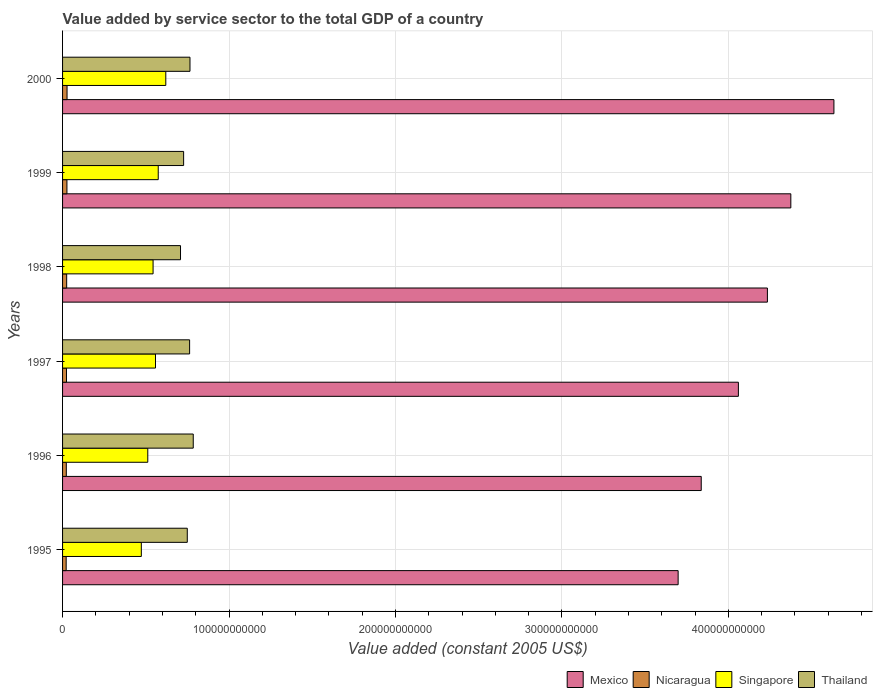Are the number of bars per tick equal to the number of legend labels?
Your response must be concise. Yes. How many bars are there on the 6th tick from the top?
Ensure brevity in your answer.  4. What is the label of the 6th group of bars from the top?
Your response must be concise. 1995. In how many cases, is the number of bars for a given year not equal to the number of legend labels?
Ensure brevity in your answer.  0. What is the value added by service sector in Thailand in 1997?
Provide a short and direct response. 7.63e+1. Across all years, what is the maximum value added by service sector in Thailand?
Your answer should be compact. 7.85e+1. Across all years, what is the minimum value added by service sector in Mexico?
Your answer should be compact. 3.70e+11. In which year was the value added by service sector in Singapore maximum?
Provide a short and direct response. 2000. What is the total value added by service sector in Mexico in the graph?
Provide a succinct answer. 2.48e+12. What is the difference between the value added by service sector in Mexico in 1995 and that in 1999?
Provide a succinct answer. -6.77e+1. What is the difference between the value added by service sector in Thailand in 1996 and the value added by service sector in Singapore in 1998?
Your answer should be compact. 2.41e+1. What is the average value added by service sector in Singapore per year?
Keep it short and to the point. 5.47e+1. In the year 2000, what is the difference between the value added by service sector in Singapore and value added by service sector in Nicaragua?
Your response must be concise. 5.93e+1. In how many years, is the value added by service sector in Mexico greater than 220000000000 US$?
Give a very brief answer. 6. What is the ratio of the value added by service sector in Thailand in 1995 to that in 1999?
Provide a short and direct response. 1.03. Is the value added by service sector in Thailand in 1997 less than that in 1999?
Provide a succinct answer. No. What is the difference between the highest and the second highest value added by service sector in Nicaragua?
Make the answer very short. 5.96e+07. What is the difference between the highest and the lowest value added by service sector in Mexico?
Offer a terse response. 9.36e+1. Is the sum of the value added by service sector in Thailand in 1997 and 1999 greater than the maximum value added by service sector in Singapore across all years?
Offer a terse response. Yes. Is it the case that in every year, the sum of the value added by service sector in Singapore and value added by service sector in Mexico is greater than the sum of value added by service sector in Nicaragua and value added by service sector in Thailand?
Offer a very short reply. Yes. What does the 1st bar from the top in 1999 represents?
Your answer should be compact. Thailand. What does the 4th bar from the bottom in 1995 represents?
Your answer should be very brief. Thailand. Is it the case that in every year, the sum of the value added by service sector in Nicaragua and value added by service sector in Thailand is greater than the value added by service sector in Singapore?
Provide a short and direct response. Yes. How many years are there in the graph?
Give a very brief answer. 6. What is the difference between two consecutive major ticks on the X-axis?
Offer a very short reply. 1.00e+11. What is the title of the graph?
Your answer should be very brief. Value added by service sector to the total GDP of a country. What is the label or title of the X-axis?
Your answer should be compact. Value added (constant 2005 US$). What is the label or title of the Y-axis?
Keep it short and to the point. Years. What is the Value added (constant 2005 US$) of Mexico in 1995?
Make the answer very short. 3.70e+11. What is the Value added (constant 2005 US$) in Nicaragua in 1995?
Give a very brief answer. 2.17e+09. What is the Value added (constant 2005 US$) of Singapore in 1995?
Give a very brief answer. 4.73e+1. What is the Value added (constant 2005 US$) of Thailand in 1995?
Your answer should be compact. 7.49e+1. What is the Value added (constant 2005 US$) of Mexico in 1996?
Keep it short and to the point. 3.84e+11. What is the Value added (constant 2005 US$) in Nicaragua in 1996?
Keep it short and to the point. 2.26e+09. What is the Value added (constant 2005 US$) of Singapore in 1996?
Your answer should be compact. 5.12e+1. What is the Value added (constant 2005 US$) of Thailand in 1996?
Keep it short and to the point. 7.85e+1. What is the Value added (constant 2005 US$) of Mexico in 1997?
Ensure brevity in your answer.  4.06e+11. What is the Value added (constant 2005 US$) of Nicaragua in 1997?
Your response must be concise. 2.37e+09. What is the Value added (constant 2005 US$) in Singapore in 1997?
Provide a short and direct response. 5.58e+1. What is the Value added (constant 2005 US$) of Thailand in 1997?
Make the answer very short. 7.63e+1. What is the Value added (constant 2005 US$) in Mexico in 1998?
Provide a succinct answer. 4.23e+11. What is the Value added (constant 2005 US$) of Nicaragua in 1998?
Offer a very short reply. 2.47e+09. What is the Value added (constant 2005 US$) of Singapore in 1998?
Your answer should be very brief. 5.44e+1. What is the Value added (constant 2005 US$) of Thailand in 1998?
Your answer should be very brief. 7.09e+1. What is the Value added (constant 2005 US$) in Mexico in 1999?
Offer a very short reply. 4.38e+11. What is the Value added (constant 2005 US$) of Nicaragua in 1999?
Make the answer very short. 2.63e+09. What is the Value added (constant 2005 US$) in Singapore in 1999?
Your response must be concise. 5.75e+1. What is the Value added (constant 2005 US$) in Thailand in 1999?
Offer a very short reply. 7.27e+1. What is the Value added (constant 2005 US$) of Mexico in 2000?
Give a very brief answer. 4.63e+11. What is the Value added (constant 2005 US$) in Nicaragua in 2000?
Your answer should be very brief. 2.69e+09. What is the Value added (constant 2005 US$) of Singapore in 2000?
Ensure brevity in your answer.  6.20e+1. What is the Value added (constant 2005 US$) in Thailand in 2000?
Keep it short and to the point. 7.66e+1. Across all years, what is the maximum Value added (constant 2005 US$) of Mexico?
Your answer should be very brief. 4.63e+11. Across all years, what is the maximum Value added (constant 2005 US$) of Nicaragua?
Provide a short and direct response. 2.69e+09. Across all years, what is the maximum Value added (constant 2005 US$) of Singapore?
Provide a short and direct response. 6.20e+1. Across all years, what is the maximum Value added (constant 2005 US$) of Thailand?
Provide a short and direct response. 7.85e+1. Across all years, what is the minimum Value added (constant 2005 US$) in Mexico?
Your answer should be very brief. 3.70e+11. Across all years, what is the minimum Value added (constant 2005 US$) in Nicaragua?
Your answer should be very brief. 2.17e+09. Across all years, what is the minimum Value added (constant 2005 US$) of Singapore?
Ensure brevity in your answer.  4.73e+1. Across all years, what is the minimum Value added (constant 2005 US$) of Thailand?
Provide a succinct answer. 7.09e+1. What is the total Value added (constant 2005 US$) of Mexico in the graph?
Offer a very short reply. 2.48e+12. What is the total Value added (constant 2005 US$) of Nicaragua in the graph?
Provide a short and direct response. 1.46e+1. What is the total Value added (constant 2005 US$) of Singapore in the graph?
Make the answer very short. 3.28e+11. What is the total Value added (constant 2005 US$) in Thailand in the graph?
Provide a succinct answer. 4.50e+11. What is the difference between the Value added (constant 2005 US$) in Mexico in 1995 and that in 1996?
Your response must be concise. -1.39e+1. What is the difference between the Value added (constant 2005 US$) in Nicaragua in 1995 and that in 1996?
Your answer should be very brief. -8.45e+07. What is the difference between the Value added (constant 2005 US$) in Singapore in 1995 and that in 1996?
Provide a succinct answer. -3.88e+09. What is the difference between the Value added (constant 2005 US$) of Thailand in 1995 and that in 1996?
Give a very brief answer. -3.58e+09. What is the difference between the Value added (constant 2005 US$) of Mexico in 1995 and that in 1997?
Your response must be concise. -3.62e+1. What is the difference between the Value added (constant 2005 US$) in Nicaragua in 1995 and that in 1997?
Your response must be concise. -1.96e+08. What is the difference between the Value added (constant 2005 US$) in Singapore in 1995 and that in 1997?
Provide a short and direct response. -8.52e+09. What is the difference between the Value added (constant 2005 US$) in Thailand in 1995 and that in 1997?
Your answer should be very brief. -1.40e+09. What is the difference between the Value added (constant 2005 US$) in Mexico in 1995 and that in 1998?
Keep it short and to the point. -5.36e+1. What is the difference between the Value added (constant 2005 US$) of Nicaragua in 1995 and that in 1998?
Your answer should be very brief. -3.01e+08. What is the difference between the Value added (constant 2005 US$) in Singapore in 1995 and that in 1998?
Offer a very short reply. -7.06e+09. What is the difference between the Value added (constant 2005 US$) of Thailand in 1995 and that in 1998?
Offer a terse response. 4.07e+09. What is the difference between the Value added (constant 2005 US$) of Mexico in 1995 and that in 1999?
Make the answer very short. -6.77e+1. What is the difference between the Value added (constant 2005 US$) of Nicaragua in 1995 and that in 1999?
Give a very brief answer. -4.58e+08. What is the difference between the Value added (constant 2005 US$) of Singapore in 1995 and that in 1999?
Your response must be concise. -1.02e+1. What is the difference between the Value added (constant 2005 US$) of Thailand in 1995 and that in 1999?
Ensure brevity in your answer.  2.19e+09. What is the difference between the Value added (constant 2005 US$) in Mexico in 1995 and that in 2000?
Provide a succinct answer. -9.36e+1. What is the difference between the Value added (constant 2005 US$) in Nicaragua in 1995 and that in 2000?
Make the answer very short. -5.18e+08. What is the difference between the Value added (constant 2005 US$) in Singapore in 1995 and that in 2000?
Your answer should be very brief. -1.47e+1. What is the difference between the Value added (constant 2005 US$) of Thailand in 1995 and that in 2000?
Your response must be concise. -1.63e+09. What is the difference between the Value added (constant 2005 US$) in Mexico in 1996 and that in 1997?
Give a very brief answer. -2.23e+1. What is the difference between the Value added (constant 2005 US$) of Nicaragua in 1996 and that in 1997?
Provide a succinct answer. -1.11e+08. What is the difference between the Value added (constant 2005 US$) of Singapore in 1996 and that in 1997?
Ensure brevity in your answer.  -4.64e+09. What is the difference between the Value added (constant 2005 US$) of Thailand in 1996 and that in 1997?
Give a very brief answer. 2.18e+09. What is the difference between the Value added (constant 2005 US$) in Mexico in 1996 and that in 1998?
Your response must be concise. -3.98e+1. What is the difference between the Value added (constant 2005 US$) in Nicaragua in 1996 and that in 1998?
Offer a very short reply. -2.16e+08. What is the difference between the Value added (constant 2005 US$) in Singapore in 1996 and that in 1998?
Your answer should be very brief. -3.18e+09. What is the difference between the Value added (constant 2005 US$) of Thailand in 1996 and that in 1998?
Your answer should be very brief. 7.65e+09. What is the difference between the Value added (constant 2005 US$) of Mexico in 1996 and that in 1999?
Provide a succinct answer. -5.38e+1. What is the difference between the Value added (constant 2005 US$) of Nicaragua in 1996 and that in 1999?
Offer a terse response. -3.74e+08. What is the difference between the Value added (constant 2005 US$) in Singapore in 1996 and that in 1999?
Your answer should be very brief. -6.28e+09. What is the difference between the Value added (constant 2005 US$) in Thailand in 1996 and that in 1999?
Offer a terse response. 5.78e+09. What is the difference between the Value added (constant 2005 US$) in Mexico in 1996 and that in 2000?
Give a very brief answer. -7.97e+1. What is the difference between the Value added (constant 2005 US$) in Nicaragua in 1996 and that in 2000?
Ensure brevity in your answer.  -4.33e+08. What is the difference between the Value added (constant 2005 US$) in Singapore in 1996 and that in 2000?
Your answer should be very brief. -1.08e+1. What is the difference between the Value added (constant 2005 US$) of Thailand in 1996 and that in 2000?
Give a very brief answer. 1.96e+09. What is the difference between the Value added (constant 2005 US$) of Mexico in 1997 and that in 1998?
Your response must be concise. -1.74e+1. What is the difference between the Value added (constant 2005 US$) in Nicaragua in 1997 and that in 1998?
Provide a succinct answer. -1.05e+08. What is the difference between the Value added (constant 2005 US$) of Singapore in 1997 and that in 1998?
Offer a very short reply. 1.46e+09. What is the difference between the Value added (constant 2005 US$) in Thailand in 1997 and that in 1998?
Keep it short and to the point. 5.47e+09. What is the difference between the Value added (constant 2005 US$) in Mexico in 1997 and that in 1999?
Ensure brevity in your answer.  -3.15e+1. What is the difference between the Value added (constant 2005 US$) in Nicaragua in 1997 and that in 1999?
Ensure brevity in your answer.  -2.62e+08. What is the difference between the Value added (constant 2005 US$) in Singapore in 1997 and that in 1999?
Offer a terse response. -1.64e+09. What is the difference between the Value added (constant 2005 US$) in Thailand in 1997 and that in 1999?
Provide a short and direct response. 3.59e+09. What is the difference between the Value added (constant 2005 US$) of Mexico in 1997 and that in 2000?
Your answer should be very brief. -5.74e+1. What is the difference between the Value added (constant 2005 US$) of Nicaragua in 1997 and that in 2000?
Your answer should be very brief. -3.22e+08. What is the difference between the Value added (constant 2005 US$) of Singapore in 1997 and that in 2000?
Provide a succinct answer. -6.18e+09. What is the difference between the Value added (constant 2005 US$) in Thailand in 1997 and that in 2000?
Make the answer very short. -2.27e+08. What is the difference between the Value added (constant 2005 US$) of Mexico in 1998 and that in 1999?
Provide a short and direct response. -1.41e+1. What is the difference between the Value added (constant 2005 US$) of Nicaragua in 1998 and that in 1999?
Offer a terse response. -1.57e+08. What is the difference between the Value added (constant 2005 US$) in Singapore in 1998 and that in 1999?
Keep it short and to the point. -3.10e+09. What is the difference between the Value added (constant 2005 US$) of Thailand in 1998 and that in 1999?
Provide a short and direct response. -1.87e+09. What is the difference between the Value added (constant 2005 US$) in Mexico in 1998 and that in 2000?
Make the answer very short. -4.00e+1. What is the difference between the Value added (constant 2005 US$) of Nicaragua in 1998 and that in 2000?
Your answer should be compact. -2.17e+08. What is the difference between the Value added (constant 2005 US$) of Singapore in 1998 and that in 2000?
Provide a succinct answer. -7.64e+09. What is the difference between the Value added (constant 2005 US$) of Thailand in 1998 and that in 2000?
Your answer should be compact. -5.69e+09. What is the difference between the Value added (constant 2005 US$) of Mexico in 1999 and that in 2000?
Offer a very short reply. -2.59e+1. What is the difference between the Value added (constant 2005 US$) in Nicaragua in 1999 and that in 2000?
Provide a succinct answer. -5.96e+07. What is the difference between the Value added (constant 2005 US$) of Singapore in 1999 and that in 2000?
Make the answer very short. -4.54e+09. What is the difference between the Value added (constant 2005 US$) in Thailand in 1999 and that in 2000?
Your answer should be compact. -3.82e+09. What is the difference between the Value added (constant 2005 US$) of Mexico in 1995 and the Value added (constant 2005 US$) of Nicaragua in 1996?
Offer a terse response. 3.68e+11. What is the difference between the Value added (constant 2005 US$) in Mexico in 1995 and the Value added (constant 2005 US$) in Singapore in 1996?
Your answer should be compact. 3.19e+11. What is the difference between the Value added (constant 2005 US$) of Mexico in 1995 and the Value added (constant 2005 US$) of Thailand in 1996?
Make the answer very short. 2.91e+11. What is the difference between the Value added (constant 2005 US$) of Nicaragua in 1995 and the Value added (constant 2005 US$) of Singapore in 1996?
Your answer should be compact. -4.90e+1. What is the difference between the Value added (constant 2005 US$) in Nicaragua in 1995 and the Value added (constant 2005 US$) in Thailand in 1996?
Make the answer very short. -7.63e+1. What is the difference between the Value added (constant 2005 US$) in Singapore in 1995 and the Value added (constant 2005 US$) in Thailand in 1996?
Ensure brevity in your answer.  -3.12e+1. What is the difference between the Value added (constant 2005 US$) of Mexico in 1995 and the Value added (constant 2005 US$) of Nicaragua in 1997?
Your response must be concise. 3.67e+11. What is the difference between the Value added (constant 2005 US$) in Mexico in 1995 and the Value added (constant 2005 US$) in Singapore in 1997?
Your answer should be compact. 3.14e+11. What is the difference between the Value added (constant 2005 US$) of Mexico in 1995 and the Value added (constant 2005 US$) of Thailand in 1997?
Your answer should be compact. 2.94e+11. What is the difference between the Value added (constant 2005 US$) in Nicaragua in 1995 and the Value added (constant 2005 US$) in Singapore in 1997?
Provide a short and direct response. -5.37e+1. What is the difference between the Value added (constant 2005 US$) in Nicaragua in 1995 and the Value added (constant 2005 US$) in Thailand in 1997?
Your response must be concise. -7.42e+1. What is the difference between the Value added (constant 2005 US$) in Singapore in 1995 and the Value added (constant 2005 US$) in Thailand in 1997?
Offer a terse response. -2.90e+1. What is the difference between the Value added (constant 2005 US$) of Mexico in 1995 and the Value added (constant 2005 US$) of Nicaragua in 1998?
Provide a short and direct response. 3.67e+11. What is the difference between the Value added (constant 2005 US$) in Mexico in 1995 and the Value added (constant 2005 US$) in Singapore in 1998?
Offer a terse response. 3.15e+11. What is the difference between the Value added (constant 2005 US$) of Mexico in 1995 and the Value added (constant 2005 US$) of Thailand in 1998?
Your answer should be compact. 2.99e+11. What is the difference between the Value added (constant 2005 US$) of Nicaragua in 1995 and the Value added (constant 2005 US$) of Singapore in 1998?
Make the answer very short. -5.22e+1. What is the difference between the Value added (constant 2005 US$) of Nicaragua in 1995 and the Value added (constant 2005 US$) of Thailand in 1998?
Offer a terse response. -6.87e+1. What is the difference between the Value added (constant 2005 US$) in Singapore in 1995 and the Value added (constant 2005 US$) in Thailand in 1998?
Ensure brevity in your answer.  -2.35e+1. What is the difference between the Value added (constant 2005 US$) in Mexico in 1995 and the Value added (constant 2005 US$) in Nicaragua in 1999?
Provide a succinct answer. 3.67e+11. What is the difference between the Value added (constant 2005 US$) in Mexico in 1995 and the Value added (constant 2005 US$) in Singapore in 1999?
Your answer should be very brief. 3.12e+11. What is the difference between the Value added (constant 2005 US$) of Mexico in 1995 and the Value added (constant 2005 US$) of Thailand in 1999?
Your answer should be very brief. 2.97e+11. What is the difference between the Value added (constant 2005 US$) of Nicaragua in 1995 and the Value added (constant 2005 US$) of Singapore in 1999?
Ensure brevity in your answer.  -5.53e+1. What is the difference between the Value added (constant 2005 US$) of Nicaragua in 1995 and the Value added (constant 2005 US$) of Thailand in 1999?
Your answer should be compact. -7.06e+1. What is the difference between the Value added (constant 2005 US$) in Singapore in 1995 and the Value added (constant 2005 US$) in Thailand in 1999?
Provide a short and direct response. -2.54e+1. What is the difference between the Value added (constant 2005 US$) of Mexico in 1995 and the Value added (constant 2005 US$) of Nicaragua in 2000?
Ensure brevity in your answer.  3.67e+11. What is the difference between the Value added (constant 2005 US$) of Mexico in 1995 and the Value added (constant 2005 US$) of Singapore in 2000?
Your response must be concise. 3.08e+11. What is the difference between the Value added (constant 2005 US$) in Mexico in 1995 and the Value added (constant 2005 US$) in Thailand in 2000?
Offer a terse response. 2.93e+11. What is the difference between the Value added (constant 2005 US$) in Nicaragua in 1995 and the Value added (constant 2005 US$) in Singapore in 2000?
Offer a very short reply. -5.98e+1. What is the difference between the Value added (constant 2005 US$) in Nicaragua in 1995 and the Value added (constant 2005 US$) in Thailand in 2000?
Ensure brevity in your answer.  -7.44e+1. What is the difference between the Value added (constant 2005 US$) of Singapore in 1995 and the Value added (constant 2005 US$) of Thailand in 2000?
Provide a succinct answer. -2.92e+1. What is the difference between the Value added (constant 2005 US$) in Mexico in 1996 and the Value added (constant 2005 US$) in Nicaragua in 1997?
Ensure brevity in your answer.  3.81e+11. What is the difference between the Value added (constant 2005 US$) of Mexico in 1996 and the Value added (constant 2005 US$) of Singapore in 1997?
Make the answer very short. 3.28e+11. What is the difference between the Value added (constant 2005 US$) of Mexico in 1996 and the Value added (constant 2005 US$) of Thailand in 1997?
Offer a very short reply. 3.07e+11. What is the difference between the Value added (constant 2005 US$) of Nicaragua in 1996 and the Value added (constant 2005 US$) of Singapore in 1997?
Provide a succinct answer. -5.36e+1. What is the difference between the Value added (constant 2005 US$) in Nicaragua in 1996 and the Value added (constant 2005 US$) in Thailand in 1997?
Make the answer very short. -7.41e+1. What is the difference between the Value added (constant 2005 US$) in Singapore in 1996 and the Value added (constant 2005 US$) in Thailand in 1997?
Your response must be concise. -2.51e+1. What is the difference between the Value added (constant 2005 US$) in Mexico in 1996 and the Value added (constant 2005 US$) in Nicaragua in 1998?
Keep it short and to the point. 3.81e+11. What is the difference between the Value added (constant 2005 US$) of Mexico in 1996 and the Value added (constant 2005 US$) of Singapore in 1998?
Keep it short and to the point. 3.29e+11. What is the difference between the Value added (constant 2005 US$) in Mexico in 1996 and the Value added (constant 2005 US$) in Thailand in 1998?
Your answer should be compact. 3.13e+11. What is the difference between the Value added (constant 2005 US$) in Nicaragua in 1996 and the Value added (constant 2005 US$) in Singapore in 1998?
Your response must be concise. -5.21e+1. What is the difference between the Value added (constant 2005 US$) of Nicaragua in 1996 and the Value added (constant 2005 US$) of Thailand in 1998?
Offer a terse response. -6.86e+1. What is the difference between the Value added (constant 2005 US$) of Singapore in 1996 and the Value added (constant 2005 US$) of Thailand in 1998?
Offer a terse response. -1.97e+1. What is the difference between the Value added (constant 2005 US$) in Mexico in 1996 and the Value added (constant 2005 US$) in Nicaragua in 1999?
Your answer should be compact. 3.81e+11. What is the difference between the Value added (constant 2005 US$) in Mexico in 1996 and the Value added (constant 2005 US$) in Singapore in 1999?
Ensure brevity in your answer.  3.26e+11. What is the difference between the Value added (constant 2005 US$) of Mexico in 1996 and the Value added (constant 2005 US$) of Thailand in 1999?
Make the answer very short. 3.11e+11. What is the difference between the Value added (constant 2005 US$) in Nicaragua in 1996 and the Value added (constant 2005 US$) in Singapore in 1999?
Provide a succinct answer. -5.52e+1. What is the difference between the Value added (constant 2005 US$) in Nicaragua in 1996 and the Value added (constant 2005 US$) in Thailand in 1999?
Your answer should be compact. -7.05e+1. What is the difference between the Value added (constant 2005 US$) in Singapore in 1996 and the Value added (constant 2005 US$) in Thailand in 1999?
Offer a very short reply. -2.15e+1. What is the difference between the Value added (constant 2005 US$) of Mexico in 1996 and the Value added (constant 2005 US$) of Nicaragua in 2000?
Provide a succinct answer. 3.81e+11. What is the difference between the Value added (constant 2005 US$) in Mexico in 1996 and the Value added (constant 2005 US$) in Singapore in 2000?
Your response must be concise. 3.22e+11. What is the difference between the Value added (constant 2005 US$) of Mexico in 1996 and the Value added (constant 2005 US$) of Thailand in 2000?
Give a very brief answer. 3.07e+11. What is the difference between the Value added (constant 2005 US$) in Nicaragua in 1996 and the Value added (constant 2005 US$) in Singapore in 2000?
Provide a short and direct response. -5.98e+1. What is the difference between the Value added (constant 2005 US$) in Nicaragua in 1996 and the Value added (constant 2005 US$) in Thailand in 2000?
Ensure brevity in your answer.  -7.43e+1. What is the difference between the Value added (constant 2005 US$) in Singapore in 1996 and the Value added (constant 2005 US$) in Thailand in 2000?
Provide a short and direct response. -2.54e+1. What is the difference between the Value added (constant 2005 US$) of Mexico in 1997 and the Value added (constant 2005 US$) of Nicaragua in 1998?
Your answer should be very brief. 4.04e+11. What is the difference between the Value added (constant 2005 US$) in Mexico in 1997 and the Value added (constant 2005 US$) in Singapore in 1998?
Offer a terse response. 3.52e+11. What is the difference between the Value added (constant 2005 US$) of Mexico in 1997 and the Value added (constant 2005 US$) of Thailand in 1998?
Your answer should be compact. 3.35e+11. What is the difference between the Value added (constant 2005 US$) in Nicaragua in 1997 and the Value added (constant 2005 US$) in Singapore in 1998?
Offer a very short reply. -5.20e+1. What is the difference between the Value added (constant 2005 US$) of Nicaragua in 1997 and the Value added (constant 2005 US$) of Thailand in 1998?
Your response must be concise. -6.85e+1. What is the difference between the Value added (constant 2005 US$) in Singapore in 1997 and the Value added (constant 2005 US$) in Thailand in 1998?
Give a very brief answer. -1.50e+1. What is the difference between the Value added (constant 2005 US$) in Mexico in 1997 and the Value added (constant 2005 US$) in Nicaragua in 1999?
Your answer should be compact. 4.03e+11. What is the difference between the Value added (constant 2005 US$) of Mexico in 1997 and the Value added (constant 2005 US$) of Singapore in 1999?
Your answer should be compact. 3.49e+11. What is the difference between the Value added (constant 2005 US$) in Mexico in 1997 and the Value added (constant 2005 US$) in Thailand in 1999?
Provide a short and direct response. 3.33e+11. What is the difference between the Value added (constant 2005 US$) in Nicaragua in 1997 and the Value added (constant 2005 US$) in Singapore in 1999?
Provide a short and direct response. -5.51e+1. What is the difference between the Value added (constant 2005 US$) of Nicaragua in 1997 and the Value added (constant 2005 US$) of Thailand in 1999?
Your answer should be compact. -7.04e+1. What is the difference between the Value added (constant 2005 US$) in Singapore in 1997 and the Value added (constant 2005 US$) in Thailand in 1999?
Keep it short and to the point. -1.69e+1. What is the difference between the Value added (constant 2005 US$) of Mexico in 1997 and the Value added (constant 2005 US$) of Nicaragua in 2000?
Make the answer very short. 4.03e+11. What is the difference between the Value added (constant 2005 US$) of Mexico in 1997 and the Value added (constant 2005 US$) of Singapore in 2000?
Offer a very short reply. 3.44e+11. What is the difference between the Value added (constant 2005 US$) in Mexico in 1997 and the Value added (constant 2005 US$) in Thailand in 2000?
Keep it short and to the point. 3.29e+11. What is the difference between the Value added (constant 2005 US$) in Nicaragua in 1997 and the Value added (constant 2005 US$) in Singapore in 2000?
Your response must be concise. -5.97e+1. What is the difference between the Value added (constant 2005 US$) of Nicaragua in 1997 and the Value added (constant 2005 US$) of Thailand in 2000?
Provide a succinct answer. -7.42e+1. What is the difference between the Value added (constant 2005 US$) of Singapore in 1997 and the Value added (constant 2005 US$) of Thailand in 2000?
Your response must be concise. -2.07e+1. What is the difference between the Value added (constant 2005 US$) in Mexico in 1998 and the Value added (constant 2005 US$) in Nicaragua in 1999?
Ensure brevity in your answer.  4.21e+11. What is the difference between the Value added (constant 2005 US$) in Mexico in 1998 and the Value added (constant 2005 US$) in Singapore in 1999?
Offer a very short reply. 3.66e+11. What is the difference between the Value added (constant 2005 US$) of Mexico in 1998 and the Value added (constant 2005 US$) of Thailand in 1999?
Your response must be concise. 3.51e+11. What is the difference between the Value added (constant 2005 US$) of Nicaragua in 1998 and the Value added (constant 2005 US$) of Singapore in 1999?
Your answer should be compact. -5.50e+1. What is the difference between the Value added (constant 2005 US$) of Nicaragua in 1998 and the Value added (constant 2005 US$) of Thailand in 1999?
Your answer should be very brief. -7.03e+1. What is the difference between the Value added (constant 2005 US$) in Singapore in 1998 and the Value added (constant 2005 US$) in Thailand in 1999?
Make the answer very short. -1.84e+1. What is the difference between the Value added (constant 2005 US$) in Mexico in 1998 and the Value added (constant 2005 US$) in Nicaragua in 2000?
Offer a very short reply. 4.21e+11. What is the difference between the Value added (constant 2005 US$) in Mexico in 1998 and the Value added (constant 2005 US$) in Singapore in 2000?
Ensure brevity in your answer.  3.61e+11. What is the difference between the Value added (constant 2005 US$) of Mexico in 1998 and the Value added (constant 2005 US$) of Thailand in 2000?
Your answer should be compact. 3.47e+11. What is the difference between the Value added (constant 2005 US$) of Nicaragua in 1998 and the Value added (constant 2005 US$) of Singapore in 2000?
Provide a short and direct response. -5.95e+1. What is the difference between the Value added (constant 2005 US$) of Nicaragua in 1998 and the Value added (constant 2005 US$) of Thailand in 2000?
Provide a short and direct response. -7.41e+1. What is the difference between the Value added (constant 2005 US$) in Singapore in 1998 and the Value added (constant 2005 US$) in Thailand in 2000?
Provide a short and direct response. -2.22e+1. What is the difference between the Value added (constant 2005 US$) in Mexico in 1999 and the Value added (constant 2005 US$) in Nicaragua in 2000?
Offer a terse response. 4.35e+11. What is the difference between the Value added (constant 2005 US$) of Mexico in 1999 and the Value added (constant 2005 US$) of Singapore in 2000?
Your response must be concise. 3.76e+11. What is the difference between the Value added (constant 2005 US$) of Mexico in 1999 and the Value added (constant 2005 US$) of Thailand in 2000?
Offer a very short reply. 3.61e+11. What is the difference between the Value added (constant 2005 US$) in Nicaragua in 1999 and the Value added (constant 2005 US$) in Singapore in 2000?
Provide a succinct answer. -5.94e+1. What is the difference between the Value added (constant 2005 US$) in Nicaragua in 1999 and the Value added (constant 2005 US$) in Thailand in 2000?
Make the answer very short. -7.39e+1. What is the difference between the Value added (constant 2005 US$) of Singapore in 1999 and the Value added (constant 2005 US$) of Thailand in 2000?
Ensure brevity in your answer.  -1.91e+1. What is the average Value added (constant 2005 US$) in Mexico per year?
Keep it short and to the point. 4.14e+11. What is the average Value added (constant 2005 US$) in Nicaragua per year?
Provide a succinct answer. 2.43e+09. What is the average Value added (constant 2005 US$) in Singapore per year?
Ensure brevity in your answer.  5.47e+1. What is the average Value added (constant 2005 US$) of Thailand per year?
Your answer should be compact. 7.50e+1. In the year 1995, what is the difference between the Value added (constant 2005 US$) in Mexico and Value added (constant 2005 US$) in Nicaragua?
Offer a terse response. 3.68e+11. In the year 1995, what is the difference between the Value added (constant 2005 US$) of Mexico and Value added (constant 2005 US$) of Singapore?
Your answer should be compact. 3.23e+11. In the year 1995, what is the difference between the Value added (constant 2005 US$) of Mexico and Value added (constant 2005 US$) of Thailand?
Your answer should be very brief. 2.95e+11. In the year 1995, what is the difference between the Value added (constant 2005 US$) of Nicaragua and Value added (constant 2005 US$) of Singapore?
Provide a short and direct response. -4.52e+1. In the year 1995, what is the difference between the Value added (constant 2005 US$) of Nicaragua and Value added (constant 2005 US$) of Thailand?
Offer a very short reply. -7.28e+1. In the year 1995, what is the difference between the Value added (constant 2005 US$) in Singapore and Value added (constant 2005 US$) in Thailand?
Provide a short and direct response. -2.76e+1. In the year 1996, what is the difference between the Value added (constant 2005 US$) of Mexico and Value added (constant 2005 US$) of Nicaragua?
Offer a terse response. 3.81e+11. In the year 1996, what is the difference between the Value added (constant 2005 US$) of Mexico and Value added (constant 2005 US$) of Singapore?
Offer a terse response. 3.33e+11. In the year 1996, what is the difference between the Value added (constant 2005 US$) of Mexico and Value added (constant 2005 US$) of Thailand?
Provide a succinct answer. 3.05e+11. In the year 1996, what is the difference between the Value added (constant 2005 US$) in Nicaragua and Value added (constant 2005 US$) in Singapore?
Ensure brevity in your answer.  -4.89e+1. In the year 1996, what is the difference between the Value added (constant 2005 US$) in Nicaragua and Value added (constant 2005 US$) in Thailand?
Offer a terse response. -7.63e+1. In the year 1996, what is the difference between the Value added (constant 2005 US$) in Singapore and Value added (constant 2005 US$) in Thailand?
Give a very brief answer. -2.73e+1. In the year 1997, what is the difference between the Value added (constant 2005 US$) in Mexico and Value added (constant 2005 US$) in Nicaragua?
Your answer should be very brief. 4.04e+11. In the year 1997, what is the difference between the Value added (constant 2005 US$) in Mexico and Value added (constant 2005 US$) in Singapore?
Make the answer very short. 3.50e+11. In the year 1997, what is the difference between the Value added (constant 2005 US$) of Mexico and Value added (constant 2005 US$) of Thailand?
Your response must be concise. 3.30e+11. In the year 1997, what is the difference between the Value added (constant 2005 US$) in Nicaragua and Value added (constant 2005 US$) in Singapore?
Offer a terse response. -5.35e+1. In the year 1997, what is the difference between the Value added (constant 2005 US$) in Nicaragua and Value added (constant 2005 US$) in Thailand?
Ensure brevity in your answer.  -7.40e+1. In the year 1997, what is the difference between the Value added (constant 2005 US$) of Singapore and Value added (constant 2005 US$) of Thailand?
Offer a terse response. -2.05e+1. In the year 1998, what is the difference between the Value added (constant 2005 US$) of Mexico and Value added (constant 2005 US$) of Nicaragua?
Your answer should be compact. 4.21e+11. In the year 1998, what is the difference between the Value added (constant 2005 US$) of Mexico and Value added (constant 2005 US$) of Singapore?
Ensure brevity in your answer.  3.69e+11. In the year 1998, what is the difference between the Value added (constant 2005 US$) of Mexico and Value added (constant 2005 US$) of Thailand?
Your response must be concise. 3.53e+11. In the year 1998, what is the difference between the Value added (constant 2005 US$) of Nicaragua and Value added (constant 2005 US$) of Singapore?
Your answer should be very brief. -5.19e+1. In the year 1998, what is the difference between the Value added (constant 2005 US$) of Nicaragua and Value added (constant 2005 US$) of Thailand?
Your response must be concise. -6.84e+1. In the year 1998, what is the difference between the Value added (constant 2005 US$) in Singapore and Value added (constant 2005 US$) in Thailand?
Your response must be concise. -1.65e+1. In the year 1999, what is the difference between the Value added (constant 2005 US$) in Mexico and Value added (constant 2005 US$) in Nicaragua?
Ensure brevity in your answer.  4.35e+11. In the year 1999, what is the difference between the Value added (constant 2005 US$) of Mexico and Value added (constant 2005 US$) of Singapore?
Offer a terse response. 3.80e+11. In the year 1999, what is the difference between the Value added (constant 2005 US$) of Mexico and Value added (constant 2005 US$) of Thailand?
Keep it short and to the point. 3.65e+11. In the year 1999, what is the difference between the Value added (constant 2005 US$) of Nicaragua and Value added (constant 2005 US$) of Singapore?
Keep it short and to the point. -5.49e+1. In the year 1999, what is the difference between the Value added (constant 2005 US$) of Nicaragua and Value added (constant 2005 US$) of Thailand?
Keep it short and to the point. -7.01e+1. In the year 1999, what is the difference between the Value added (constant 2005 US$) in Singapore and Value added (constant 2005 US$) in Thailand?
Offer a terse response. -1.53e+1. In the year 2000, what is the difference between the Value added (constant 2005 US$) of Mexico and Value added (constant 2005 US$) of Nicaragua?
Provide a short and direct response. 4.61e+11. In the year 2000, what is the difference between the Value added (constant 2005 US$) of Mexico and Value added (constant 2005 US$) of Singapore?
Provide a short and direct response. 4.01e+11. In the year 2000, what is the difference between the Value added (constant 2005 US$) of Mexico and Value added (constant 2005 US$) of Thailand?
Offer a terse response. 3.87e+11. In the year 2000, what is the difference between the Value added (constant 2005 US$) in Nicaragua and Value added (constant 2005 US$) in Singapore?
Offer a terse response. -5.93e+1. In the year 2000, what is the difference between the Value added (constant 2005 US$) in Nicaragua and Value added (constant 2005 US$) in Thailand?
Your response must be concise. -7.39e+1. In the year 2000, what is the difference between the Value added (constant 2005 US$) in Singapore and Value added (constant 2005 US$) in Thailand?
Ensure brevity in your answer.  -1.45e+1. What is the ratio of the Value added (constant 2005 US$) in Mexico in 1995 to that in 1996?
Your answer should be compact. 0.96. What is the ratio of the Value added (constant 2005 US$) of Nicaragua in 1995 to that in 1996?
Keep it short and to the point. 0.96. What is the ratio of the Value added (constant 2005 US$) in Singapore in 1995 to that in 1996?
Offer a very short reply. 0.92. What is the ratio of the Value added (constant 2005 US$) of Thailand in 1995 to that in 1996?
Make the answer very short. 0.95. What is the ratio of the Value added (constant 2005 US$) in Mexico in 1995 to that in 1997?
Your answer should be compact. 0.91. What is the ratio of the Value added (constant 2005 US$) in Nicaragua in 1995 to that in 1997?
Provide a succinct answer. 0.92. What is the ratio of the Value added (constant 2005 US$) in Singapore in 1995 to that in 1997?
Keep it short and to the point. 0.85. What is the ratio of the Value added (constant 2005 US$) of Thailand in 1995 to that in 1997?
Give a very brief answer. 0.98. What is the ratio of the Value added (constant 2005 US$) of Mexico in 1995 to that in 1998?
Offer a very short reply. 0.87. What is the ratio of the Value added (constant 2005 US$) in Nicaragua in 1995 to that in 1998?
Provide a short and direct response. 0.88. What is the ratio of the Value added (constant 2005 US$) in Singapore in 1995 to that in 1998?
Give a very brief answer. 0.87. What is the ratio of the Value added (constant 2005 US$) of Thailand in 1995 to that in 1998?
Make the answer very short. 1.06. What is the ratio of the Value added (constant 2005 US$) of Mexico in 1995 to that in 1999?
Ensure brevity in your answer.  0.85. What is the ratio of the Value added (constant 2005 US$) in Nicaragua in 1995 to that in 1999?
Provide a short and direct response. 0.83. What is the ratio of the Value added (constant 2005 US$) of Singapore in 1995 to that in 1999?
Offer a terse response. 0.82. What is the ratio of the Value added (constant 2005 US$) of Thailand in 1995 to that in 1999?
Your answer should be compact. 1.03. What is the ratio of the Value added (constant 2005 US$) of Mexico in 1995 to that in 2000?
Give a very brief answer. 0.8. What is the ratio of the Value added (constant 2005 US$) in Nicaragua in 1995 to that in 2000?
Offer a terse response. 0.81. What is the ratio of the Value added (constant 2005 US$) of Singapore in 1995 to that in 2000?
Keep it short and to the point. 0.76. What is the ratio of the Value added (constant 2005 US$) in Thailand in 1995 to that in 2000?
Your response must be concise. 0.98. What is the ratio of the Value added (constant 2005 US$) of Mexico in 1996 to that in 1997?
Keep it short and to the point. 0.94. What is the ratio of the Value added (constant 2005 US$) of Nicaragua in 1996 to that in 1997?
Make the answer very short. 0.95. What is the ratio of the Value added (constant 2005 US$) of Singapore in 1996 to that in 1997?
Ensure brevity in your answer.  0.92. What is the ratio of the Value added (constant 2005 US$) in Thailand in 1996 to that in 1997?
Your answer should be very brief. 1.03. What is the ratio of the Value added (constant 2005 US$) in Mexico in 1996 to that in 1998?
Give a very brief answer. 0.91. What is the ratio of the Value added (constant 2005 US$) of Nicaragua in 1996 to that in 1998?
Your answer should be compact. 0.91. What is the ratio of the Value added (constant 2005 US$) in Singapore in 1996 to that in 1998?
Provide a succinct answer. 0.94. What is the ratio of the Value added (constant 2005 US$) in Thailand in 1996 to that in 1998?
Ensure brevity in your answer.  1.11. What is the ratio of the Value added (constant 2005 US$) in Mexico in 1996 to that in 1999?
Offer a terse response. 0.88. What is the ratio of the Value added (constant 2005 US$) of Nicaragua in 1996 to that in 1999?
Provide a short and direct response. 0.86. What is the ratio of the Value added (constant 2005 US$) of Singapore in 1996 to that in 1999?
Your answer should be compact. 0.89. What is the ratio of the Value added (constant 2005 US$) in Thailand in 1996 to that in 1999?
Provide a succinct answer. 1.08. What is the ratio of the Value added (constant 2005 US$) in Mexico in 1996 to that in 2000?
Provide a short and direct response. 0.83. What is the ratio of the Value added (constant 2005 US$) in Nicaragua in 1996 to that in 2000?
Ensure brevity in your answer.  0.84. What is the ratio of the Value added (constant 2005 US$) in Singapore in 1996 to that in 2000?
Keep it short and to the point. 0.83. What is the ratio of the Value added (constant 2005 US$) of Thailand in 1996 to that in 2000?
Your answer should be compact. 1.03. What is the ratio of the Value added (constant 2005 US$) in Mexico in 1997 to that in 1998?
Your response must be concise. 0.96. What is the ratio of the Value added (constant 2005 US$) in Nicaragua in 1997 to that in 1998?
Provide a succinct answer. 0.96. What is the ratio of the Value added (constant 2005 US$) of Singapore in 1997 to that in 1998?
Offer a very short reply. 1.03. What is the ratio of the Value added (constant 2005 US$) in Thailand in 1997 to that in 1998?
Make the answer very short. 1.08. What is the ratio of the Value added (constant 2005 US$) in Mexico in 1997 to that in 1999?
Ensure brevity in your answer.  0.93. What is the ratio of the Value added (constant 2005 US$) in Nicaragua in 1997 to that in 1999?
Offer a terse response. 0.9. What is the ratio of the Value added (constant 2005 US$) of Singapore in 1997 to that in 1999?
Offer a very short reply. 0.97. What is the ratio of the Value added (constant 2005 US$) in Thailand in 1997 to that in 1999?
Keep it short and to the point. 1.05. What is the ratio of the Value added (constant 2005 US$) in Mexico in 1997 to that in 2000?
Make the answer very short. 0.88. What is the ratio of the Value added (constant 2005 US$) in Nicaragua in 1997 to that in 2000?
Ensure brevity in your answer.  0.88. What is the ratio of the Value added (constant 2005 US$) of Singapore in 1997 to that in 2000?
Your answer should be very brief. 0.9. What is the ratio of the Value added (constant 2005 US$) of Mexico in 1998 to that in 1999?
Your response must be concise. 0.97. What is the ratio of the Value added (constant 2005 US$) of Nicaragua in 1998 to that in 1999?
Give a very brief answer. 0.94. What is the ratio of the Value added (constant 2005 US$) in Singapore in 1998 to that in 1999?
Make the answer very short. 0.95. What is the ratio of the Value added (constant 2005 US$) in Thailand in 1998 to that in 1999?
Offer a terse response. 0.97. What is the ratio of the Value added (constant 2005 US$) in Mexico in 1998 to that in 2000?
Your response must be concise. 0.91. What is the ratio of the Value added (constant 2005 US$) in Nicaragua in 1998 to that in 2000?
Keep it short and to the point. 0.92. What is the ratio of the Value added (constant 2005 US$) in Singapore in 1998 to that in 2000?
Offer a terse response. 0.88. What is the ratio of the Value added (constant 2005 US$) in Thailand in 1998 to that in 2000?
Keep it short and to the point. 0.93. What is the ratio of the Value added (constant 2005 US$) in Mexico in 1999 to that in 2000?
Your answer should be very brief. 0.94. What is the ratio of the Value added (constant 2005 US$) of Nicaragua in 1999 to that in 2000?
Ensure brevity in your answer.  0.98. What is the ratio of the Value added (constant 2005 US$) of Singapore in 1999 to that in 2000?
Offer a very short reply. 0.93. What is the ratio of the Value added (constant 2005 US$) of Thailand in 1999 to that in 2000?
Make the answer very short. 0.95. What is the difference between the highest and the second highest Value added (constant 2005 US$) in Mexico?
Your answer should be very brief. 2.59e+1. What is the difference between the highest and the second highest Value added (constant 2005 US$) in Nicaragua?
Provide a succinct answer. 5.96e+07. What is the difference between the highest and the second highest Value added (constant 2005 US$) in Singapore?
Make the answer very short. 4.54e+09. What is the difference between the highest and the second highest Value added (constant 2005 US$) in Thailand?
Your answer should be very brief. 1.96e+09. What is the difference between the highest and the lowest Value added (constant 2005 US$) of Mexico?
Provide a succinct answer. 9.36e+1. What is the difference between the highest and the lowest Value added (constant 2005 US$) of Nicaragua?
Make the answer very short. 5.18e+08. What is the difference between the highest and the lowest Value added (constant 2005 US$) of Singapore?
Your answer should be very brief. 1.47e+1. What is the difference between the highest and the lowest Value added (constant 2005 US$) of Thailand?
Keep it short and to the point. 7.65e+09. 